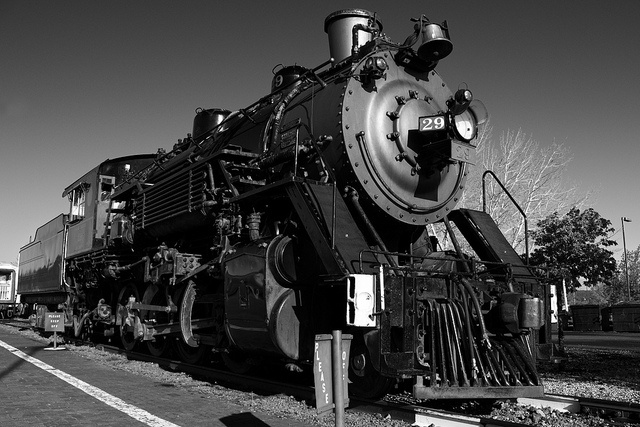Describe the objects in this image and their specific colors. I can see a train in black, gray, darkgray, and lightgray tones in this image. 